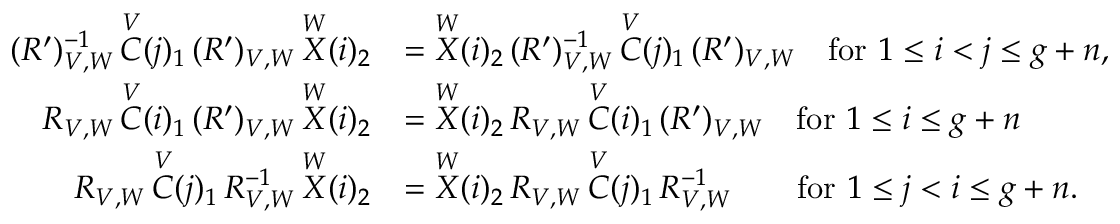<formula> <loc_0><loc_0><loc_500><loc_500>\begin{array} { r l } { ( R ^ { \prime } ) { _ { V , W } ^ { - 1 } } \, \overset { V } { C } ( j ) _ { 1 } \, ( R ^ { \prime } ) _ { V , W } \, \overset { W } { X } ( i ) _ { 2 } } & { = \overset { W } { X } ( i ) _ { 2 } \, ( R ^ { \prime } ) { _ { V , W } ^ { - 1 } } \, \overset { V } { C } ( j ) _ { 1 } \, ( R ^ { \prime } ) _ { V , W } \quad f o r 1 \leq i < j \leq g + n , } \\ { R _ { V , W } \, \overset { V } { C } ( i ) _ { 1 } \, ( R ^ { \prime } ) _ { V , W } \, \overset { W } { X } ( i ) _ { 2 } } & { = \overset { W } { X } ( i ) _ { 2 } \, R _ { V , W } \, \overset { V } { C } ( i ) _ { 1 } \, ( R ^ { \prime } ) _ { V , W } \quad f o r 1 \leq i \leq g + n } \\ { R _ { V , W } \, \overset { V } { C } ( j ) _ { 1 } \, R { _ { V , W } ^ { - 1 } } \, \overset { W } { X } ( i ) _ { 2 } } & { = \overset { W } { X } ( i ) _ { 2 } \, R _ { V , W } \, \overset { V } { C } ( j ) _ { 1 } \, R { _ { V , W } ^ { - 1 } } \quad f o r 1 \leq j < i \leq g + n . } \end{array}</formula> 